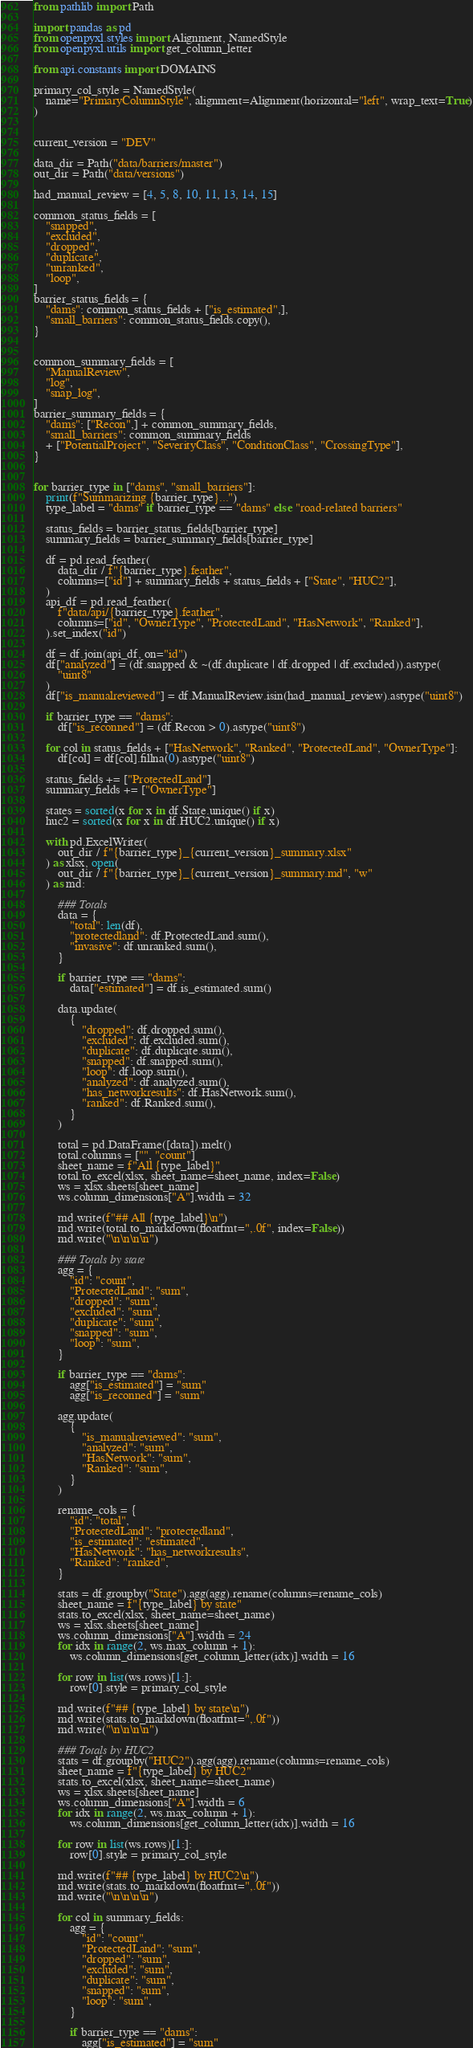<code> <loc_0><loc_0><loc_500><loc_500><_Python_>from pathlib import Path

import pandas as pd
from openpyxl.styles import Alignment, NamedStyle
from openpyxl.utils import get_column_letter

from api.constants import DOMAINS

primary_col_style = NamedStyle(
    name="PrimaryColumnStyle", alignment=Alignment(horizontal="left", wrap_text=True)
)


current_version = "DEV"

data_dir = Path("data/barriers/master")
out_dir = Path("data/versions")

had_manual_review = [4, 5, 8, 10, 11, 13, 14, 15]

common_status_fields = [
    "snapped",
    "excluded",
    "dropped",
    "duplicate",
    "unranked",
    "loop",
]
barrier_status_fields = {
    "dams": common_status_fields + ["is_estimated",],
    "small_barriers": common_status_fields.copy(),
}


common_summary_fields = [
    "ManualReview",
    "log",
    "snap_log",
]
barrier_summary_fields = {
    "dams": ["Recon",] + common_summary_fields,
    "small_barriers": common_summary_fields
    + ["PotentialProject", "SeverityClass", "ConditionClass", "CrossingType"],
}


for barrier_type in ["dams", "small_barriers"]:
    print(f"Summarizing {barrier_type}...")
    type_label = "dams" if barrier_type == "dams" else "road-related barriers"

    status_fields = barrier_status_fields[barrier_type]
    summary_fields = barrier_summary_fields[barrier_type]

    df = pd.read_feather(
        data_dir / f"{barrier_type}.feather",
        columns=["id"] + summary_fields + status_fields + ["State", "HUC2"],
    )
    api_df = pd.read_feather(
        f"data/api/{barrier_type}.feather",
        columns=["id", "OwnerType", "ProtectedLand", "HasNetwork", "Ranked"],
    ).set_index("id")

    df = df.join(api_df, on="id")
    df["analyzed"] = (df.snapped & ~(df.duplicate | df.dropped | df.excluded)).astype(
        "uint8"
    )
    df["is_manualreviewed"] = df.ManualReview.isin(had_manual_review).astype("uint8")

    if barrier_type == "dams":
        df["is_reconned"] = (df.Recon > 0).astype("uint8")

    for col in status_fields + ["HasNetwork", "Ranked", "ProtectedLand", "OwnerType"]:
        df[col] = df[col].fillna(0).astype("uint8")

    status_fields += ["ProtectedLand"]
    summary_fields += ["OwnerType"]

    states = sorted(x for x in df.State.unique() if x)
    huc2 = sorted(x for x in df.HUC2.unique() if x)

    with pd.ExcelWriter(
        out_dir / f"{barrier_type}_{current_version}_summary.xlsx"
    ) as xlsx, open(
        out_dir / f"{barrier_type}_{current_version}_summary.md", "w"
    ) as md:

        ### Totals
        data = {
            "total": len(df),
            "protectedland": df.ProtectedLand.sum(),
            "invasive": df.unranked.sum(),
        }

        if barrier_type == "dams":
            data["estimated"] = df.is_estimated.sum()

        data.update(
            {
                "dropped": df.dropped.sum(),
                "excluded": df.excluded.sum(),
                "duplicate": df.duplicate.sum(),
                "snapped": df.snapped.sum(),
                "loop": df.loop.sum(),
                "analyzed": df.analyzed.sum(),
                "has_networkresults": df.HasNetwork.sum(),
                "ranked": df.Ranked.sum(),
            }
        )

        total = pd.DataFrame([data]).melt()
        total.columns = ["", "count"]
        sheet_name = f"All {type_label}"
        total.to_excel(xlsx, sheet_name=sheet_name, index=False)
        ws = xlsx.sheets[sheet_name]
        ws.column_dimensions["A"].width = 32

        md.write(f"## All {type_label}\n")
        md.write(total.to_markdown(floatfmt=",.0f", index=False))
        md.write("\n\n\n\n")

        ### Totals by state
        agg = {
            "id": "count",
            "ProtectedLand": "sum",
            "dropped": "sum",
            "excluded": "sum",
            "duplicate": "sum",
            "snapped": "sum",
            "loop": "sum",
        }

        if barrier_type == "dams":
            agg["is_estimated"] = "sum"
            agg["is_reconned"] = "sum"

        agg.update(
            {
                "is_manualreviewed": "sum",
                "analyzed": "sum",
                "HasNetwork": "sum",
                "Ranked": "sum",
            }
        )

        rename_cols = {
            "id": "total",
            "ProtectedLand": "protectedland",
            "is_estimated": "estimated",
            "HasNetwork": "has_networkresults",
            "Ranked": "ranked",
        }

        stats = df.groupby("State").agg(agg).rename(columns=rename_cols)
        sheet_name = f"{type_label} by state"
        stats.to_excel(xlsx, sheet_name=sheet_name)
        ws = xlsx.sheets[sheet_name]
        ws.column_dimensions["A"].width = 24
        for idx in range(2, ws.max_column + 1):
            ws.column_dimensions[get_column_letter(idx)].width = 16

        for row in list(ws.rows)[1:]:
            row[0].style = primary_col_style

        md.write(f"## {type_label} by state\n")
        md.write(stats.to_markdown(floatfmt=",.0f"))
        md.write("\n\n\n\n")

        ### Totals by HUC2
        stats = df.groupby("HUC2").agg(agg).rename(columns=rename_cols)
        sheet_name = f"{type_label} by HUC2"
        stats.to_excel(xlsx, sheet_name=sheet_name)
        ws = xlsx.sheets[sheet_name]
        ws.column_dimensions["A"].width = 6
        for idx in range(2, ws.max_column + 1):
            ws.column_dimensions[get_column_letter(idx)].width = 16

        for row in list(ws.rows)[1:]:
            row[0].style = primary_col_style

        md.write(f"## {type_label} by HUC2\n")
        md.write(stats.to_markdown(floatfmt=",.0f"))
        md.write("\n\n\n\n")

        for col in summary_fields:
            agg = {
                "id": "count",
                "ProtectedLand": "sum",
                "dropped": "sum",
                "excluded": "sum",
                "duplicate": "sum",
                "snapped": "sum",
                "loop": "sum",
            }

            if barrier_type == "dams":
                agg["is_estimated"] = "sum"</code> 